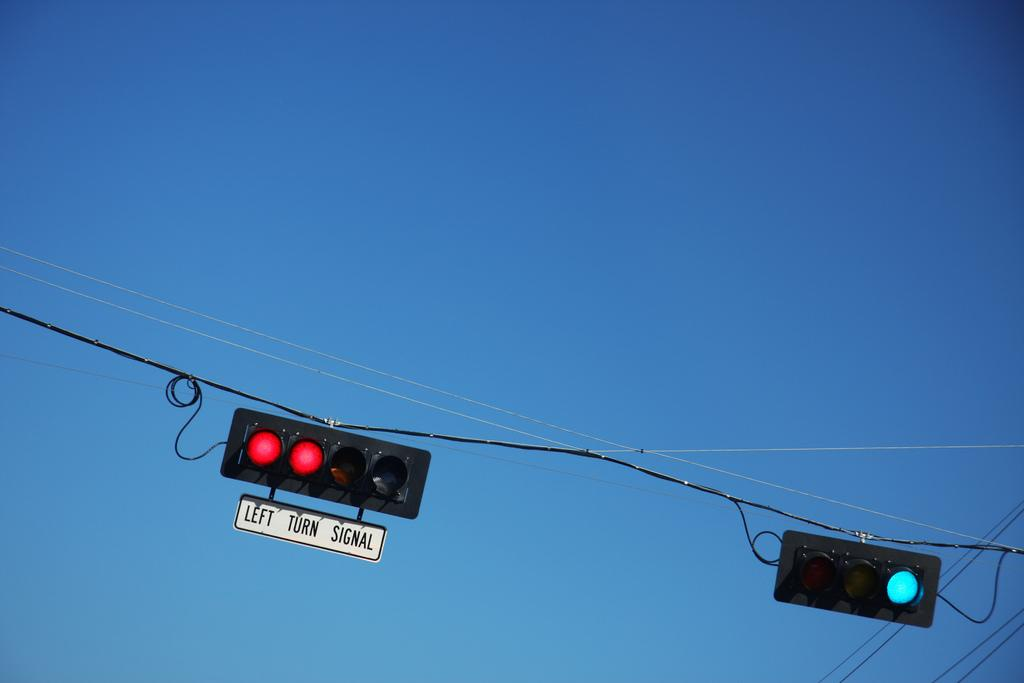<image>
Give a short and clear explanation of the subsequent image. left turn signal underneath a light that is red 